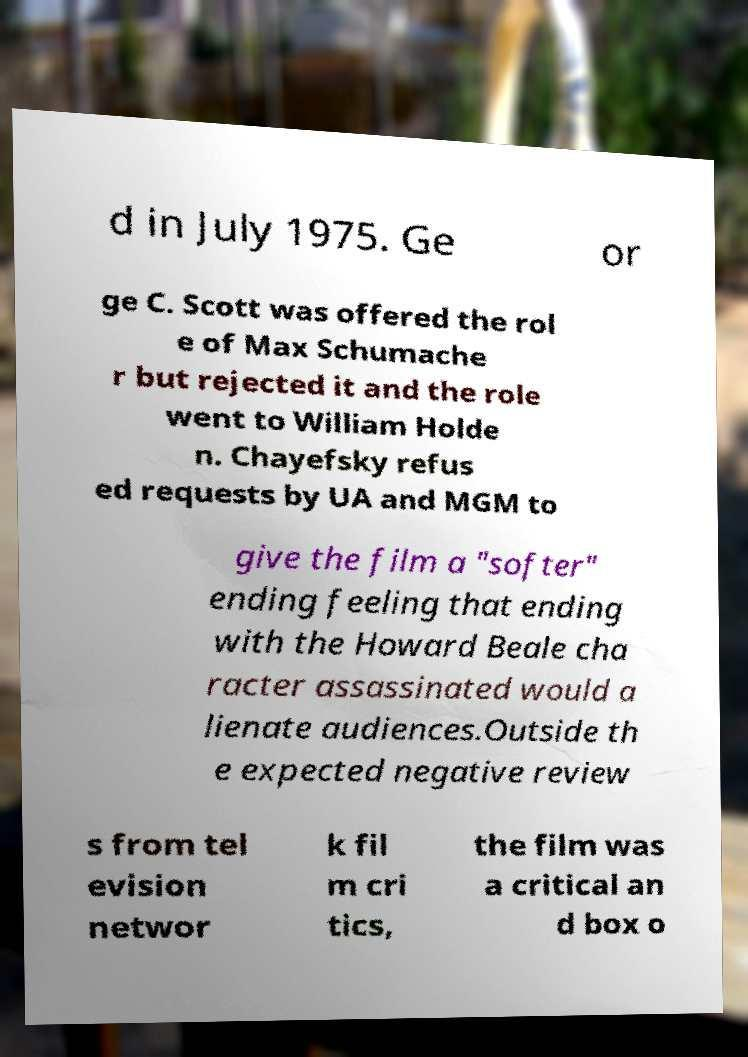Please read and relay the text visible in this image. What does it say? d in July 1975. Ge or ge C. Scott was offered the rol e of Max Schumache r but rejected it and the role went to William Holde n. Chayefsky refus ed requests by UA and MGM to give the film a "softer" ending feeling that ending with the Howard Beale cha racter assassinated would a lienate audiences.Outside th e expected negative review s from tel evision networ k fil m cri tics, the film was a critical an d box o 